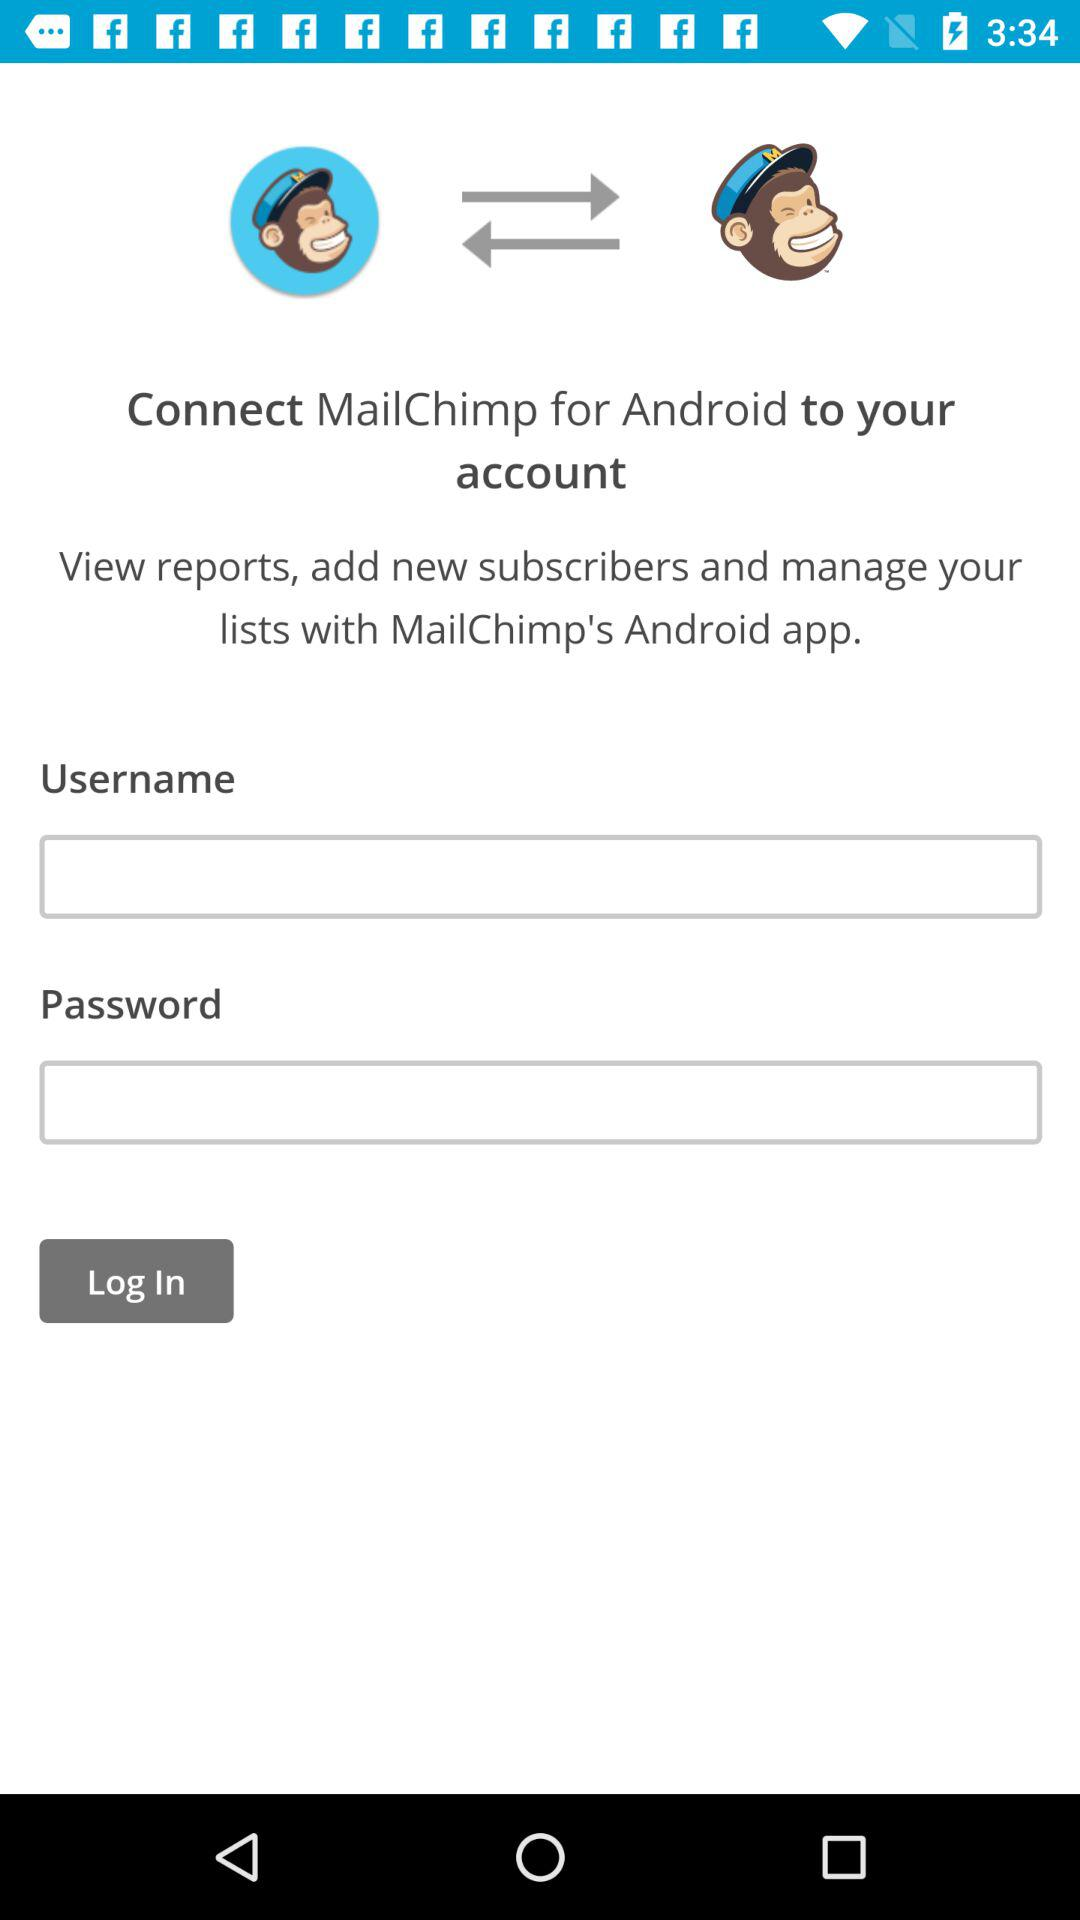Through what android application can we add new subscribers? You can add new subscribers through "MailChimp" application. 